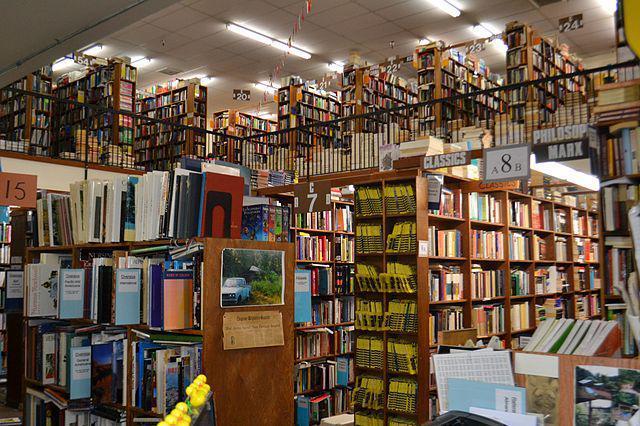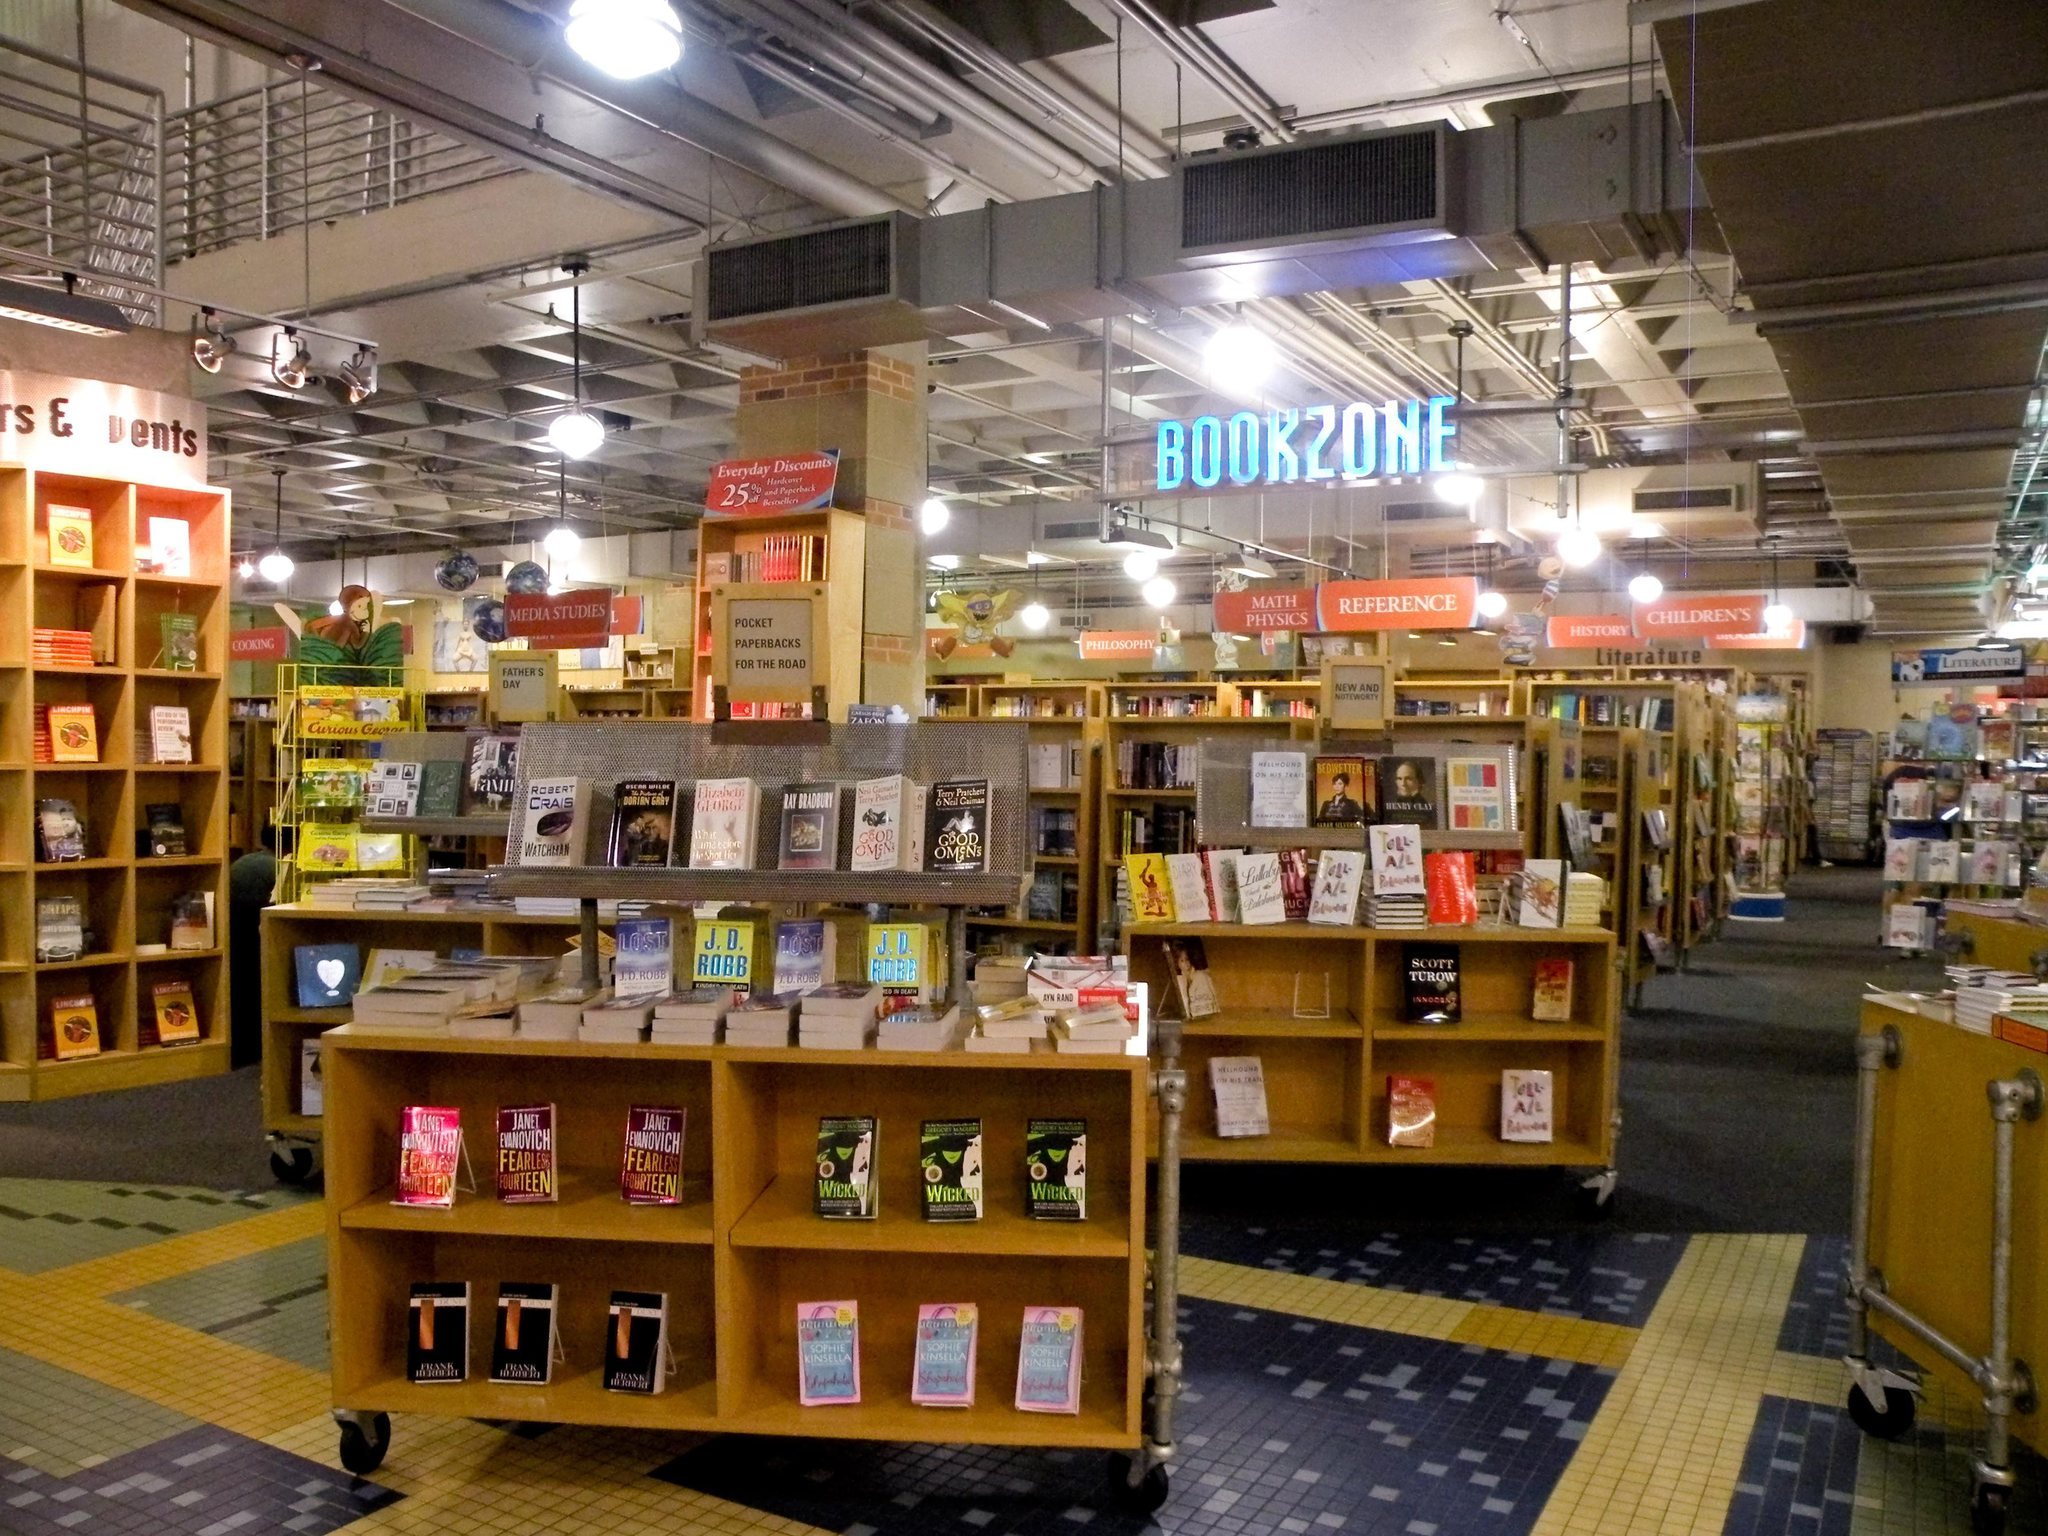The first image is the image on the left, the second image is the image on the right. Considering the images on both sides, is "There is a thin and tall standalone bookshelf in the centre of the left image." valid? Answer yes or no. No. 